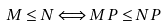<formula> <loc_0><loc_0><loc_500><loc_500>M \leq N \Longleftrightarrow M P \leq N P</formula> 